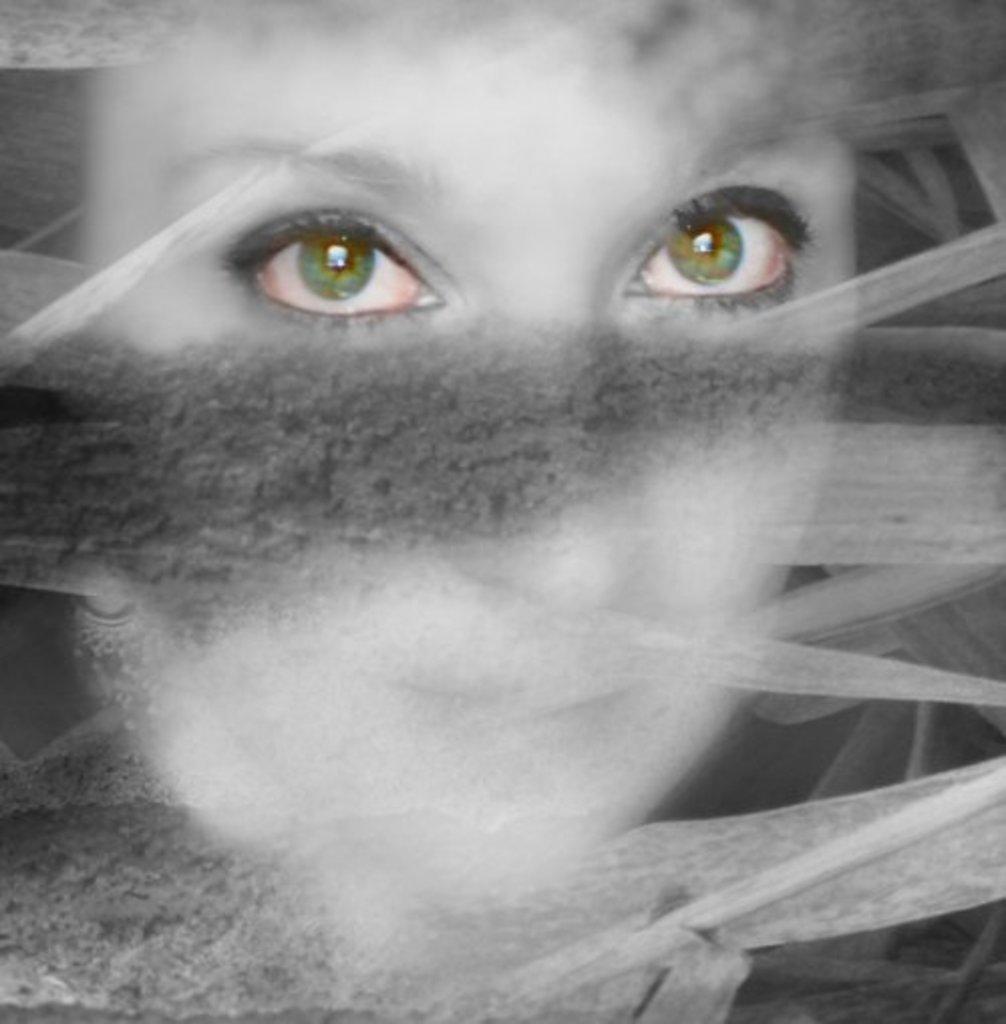In one or two sentences, can you explain what this image depicts? In this image we can see the human eyes. And the given image is not clear. 